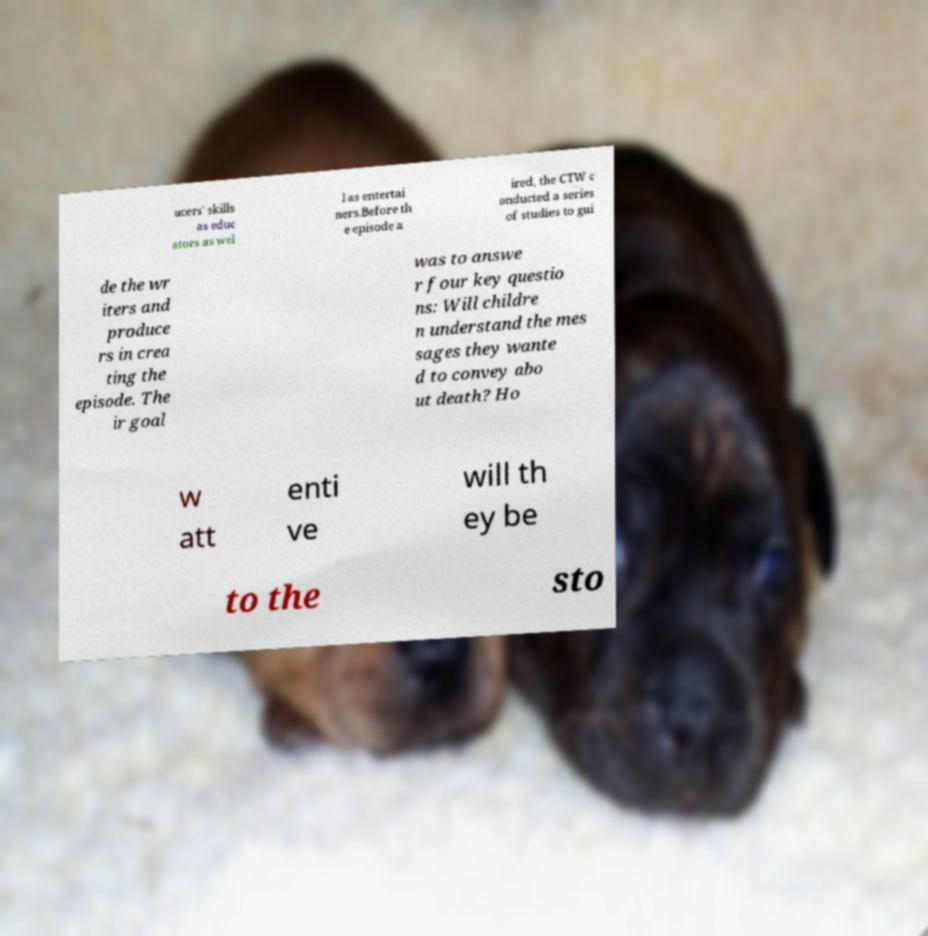There's text embedded in this image that I need extracted. Can you transcribe it verbatim? ucers' skills as educ ators as wel l as entertai ners.Before th e episode a ired, the CTW c onducted a series of studies to gui de the wr iters and produce rs in crea ting the episode. The ir goal was to answe r four key questio ns: Will childre n understand the mes sages they wante d to convey abo ut death? Ho w att enti ve will th ey be to the sto 